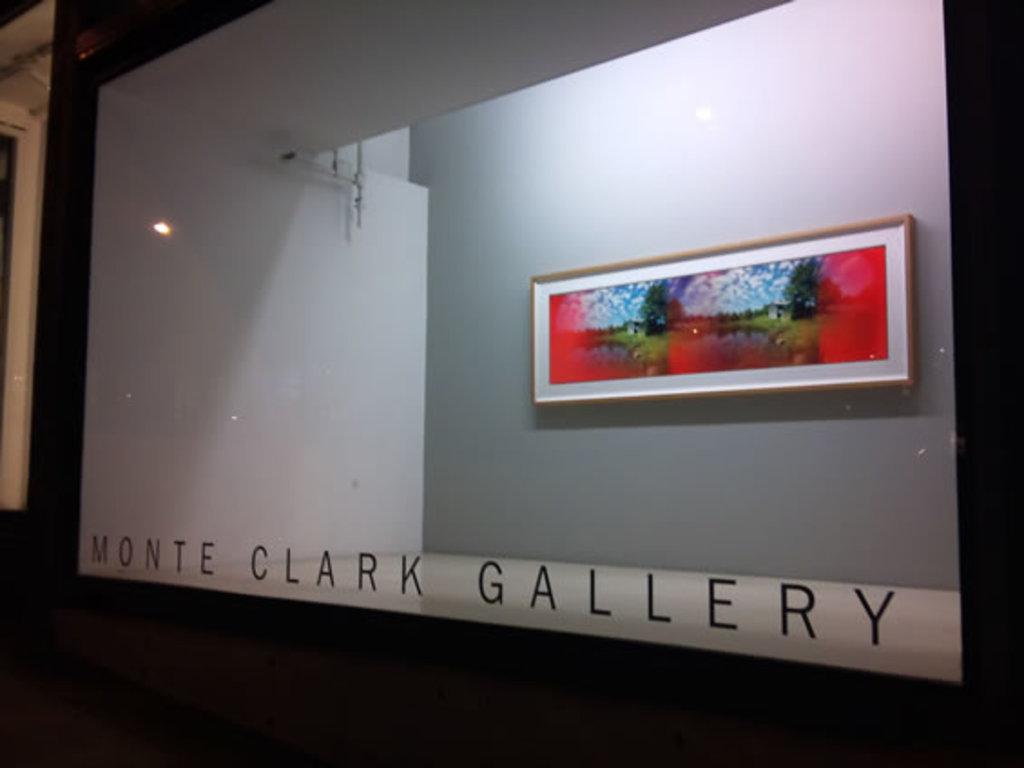What is the name of the gallery?
Ensure brevity in your answer.  Monte clark. 